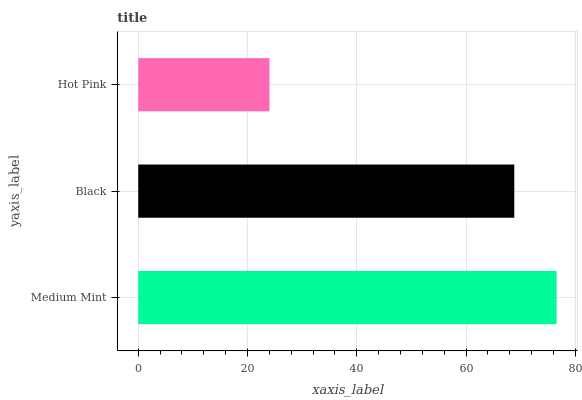Is Hot Pink the minimum?
Answer yes or no. Yes. Is Medium Mint the maximum?
Answer yes or no. Yes. Is Black the minimum?
Answer yes or no. No. Is Black the maximum?
Answer yes or no. No. Is Medium Mint greater than Black?
Answer yes or no. Yes. Is Black less than Medium Mint?
Answer yes or no. Yes. Is Black greater than Medium Mint?
Answer yes or no. No. Is Medium Mint less than Black?
Answer yes or no. No. Is Black the high median?
Answer yes or no. Yes. Is Black the low median?
Answer yes or no. Yes. Is Hot Pink the high median?
Answer yes or no. No. Is Medium Mint the low median?
Answer yes or no. No. 